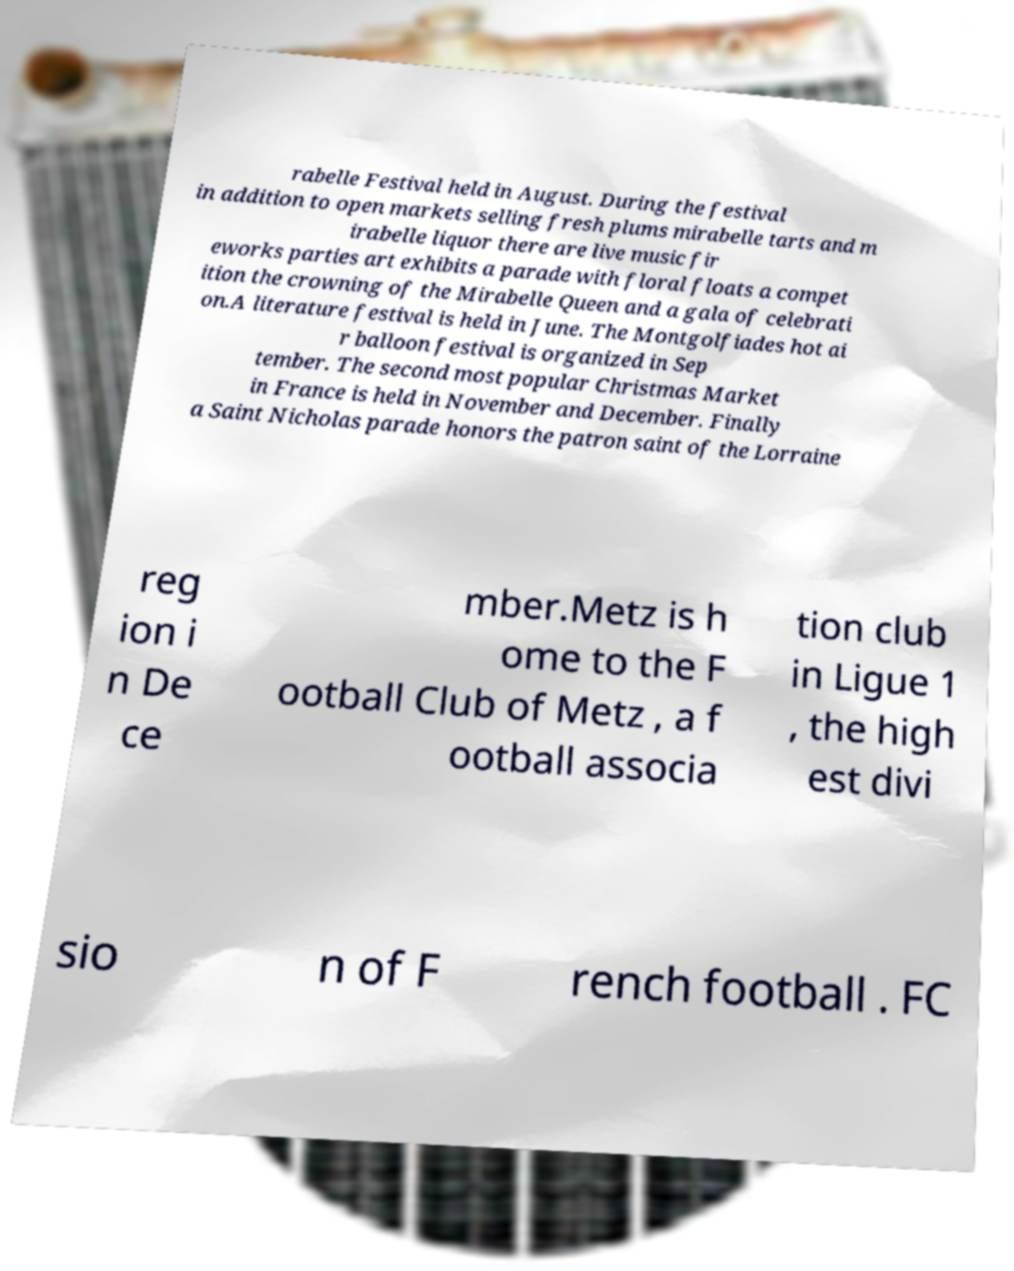Please identify and transcribe the text found in this image. rabelle Festival held in August. During the festival in addition to open markets selling fresh plums mirabelle tarts and m irabelle liquor there are live music fir eworks parties art exhibits a parade with floral floats a compet ition the crowning of the Mirabelle Queen and a gala of celebrati on.A literature festival is held in June. The Montgolfiades hot ai r balloon festival is organized in Sep tember. The second most popular Christmas Market in France is held in November and December. Finally a Saint Nicholas parade honors the patron saint of the Lorraine reg ion i n De ce mber.Metz is h ome to the F ootball Club of Metz , a f ootball associa tion club in Ligue 1 , the high est divi sio n of F rench football . FC 